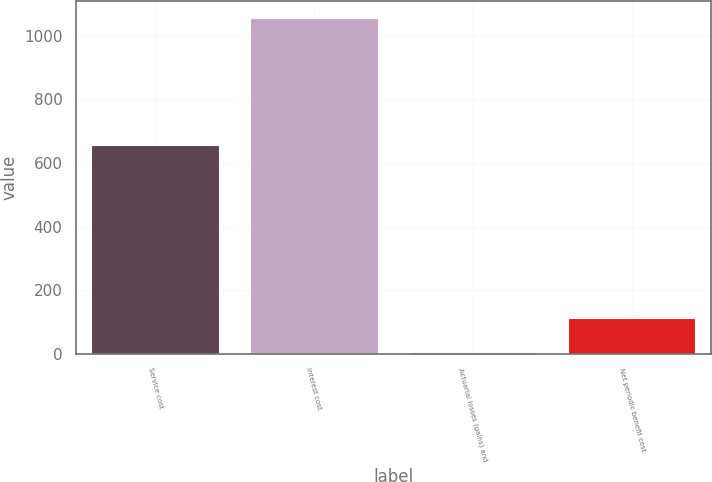<chart> <loc_0><loc_0><loc_500><loc_500><bar_chart><fcel>Service cost<fcel>Interest cost<fcel>Actuarial losses (gains) and<fcel>Net periodic benefit cost<nl><fcel>657<fcel>1055<fcel>7<fcel>111.8<nl></chart> 